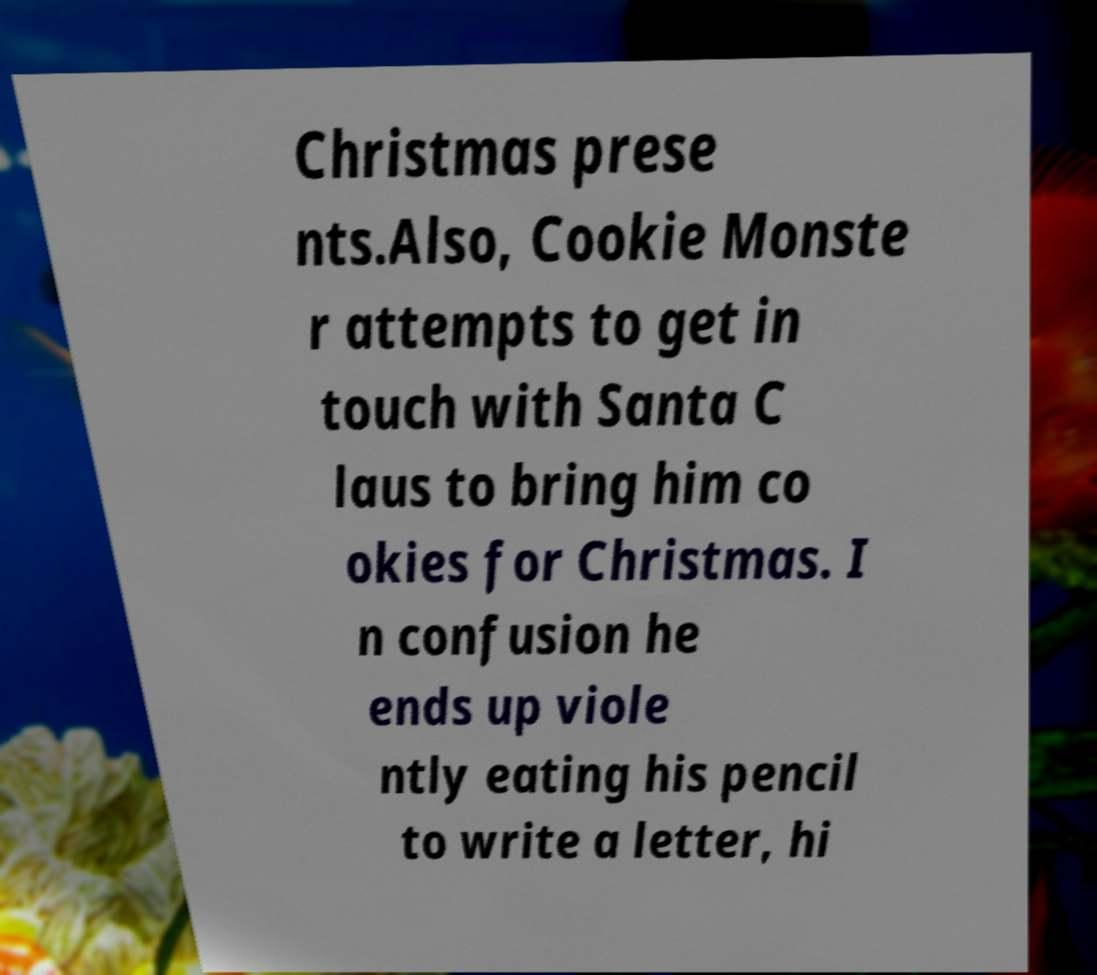What messages or text are displayed in this image? I need them in a readable, typed format. Christmas prese nts.Also, Cookie Monste r attempts to get in touch with Santa C laus to bring him co okies for Christmas. I n confusion he ends up viole ntly eating his pencil to write a letter, hi 